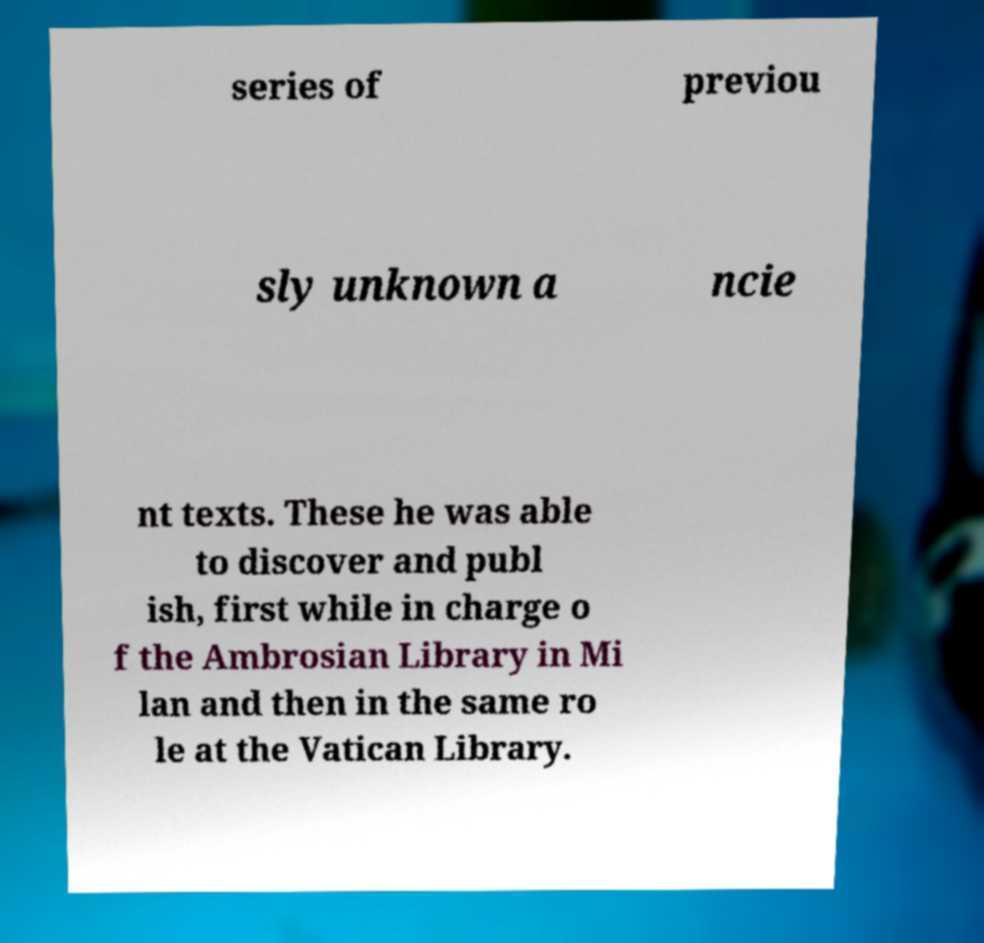Can you accurately transcribe the text from the provided image for me? series of previou sly unknown a ncie nt texts. These he was able to discover and publ ish, first while in charge o f the Ambrosian Library in Mi lan and then in the same ro le at the Vatican Library. 